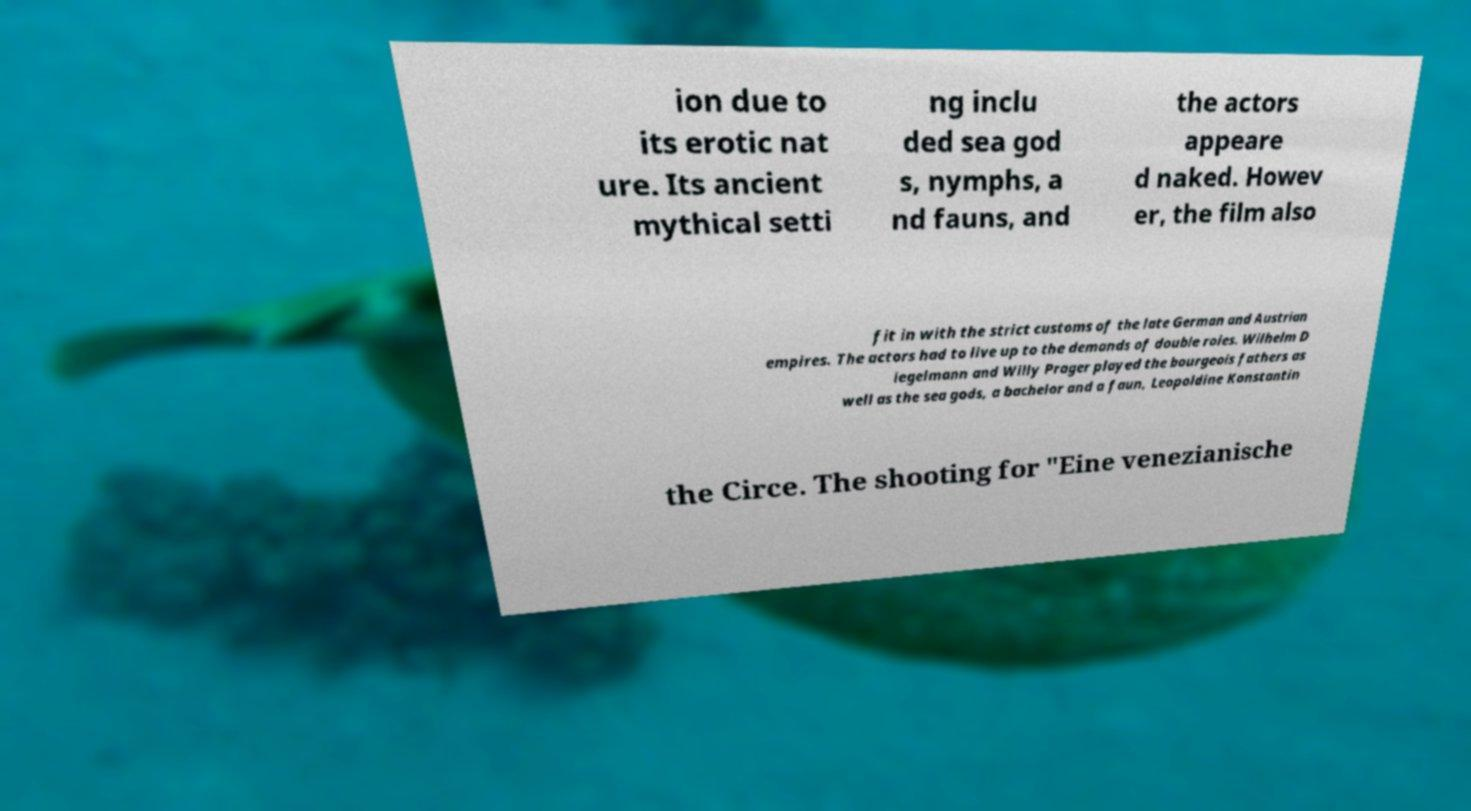Can you accurately transcribe the text from the provided image for me? ion due to its erotic nat ure. Its ancient mythical setti ng inclu ded sea god s, nymphs, a nd fauns, and the actors appeare d naked. Howev er, the film also fit in with the strict customs of the late German and Austrian empires. The actors had to live up to the demands of double roles. Wilhelm D iegelmann and Willy Prager played the bourgeois fathers as well as the sea gods, a bachelor and a faun, Leopoldine Konstantin the Circe. The shooting for "Eine venezianische 